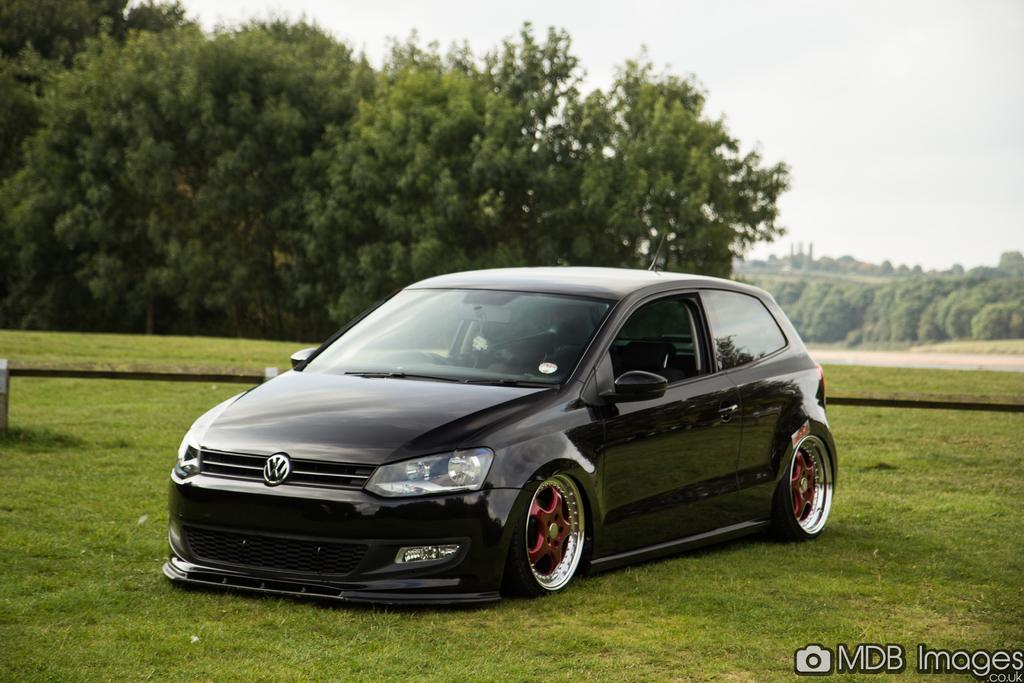What color is the car in the image? The car in the image is black. What type of vegetation can be seen in the image? There are trees in the image. What is the color of the sky in the image? The sky appears to be white in color. Where is the patch located in the image? There is no patch present in the image. What type of tooth can be seen in the image? There are no teeth present in the image. 